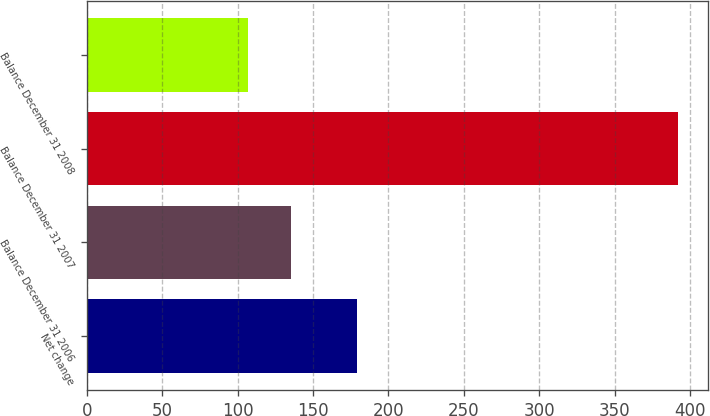Convert chart. <chart><loc_0><loc_0><loc_500><loc_500><bar_chart><fcel>Net change<fcel>Balance December 31 2006<fcel>Balance December 31 2007<fcel>Balance December 31 2008<nl><fcel>179<fcel>135.5<fcel>392<fcel>107<nl></chart> 